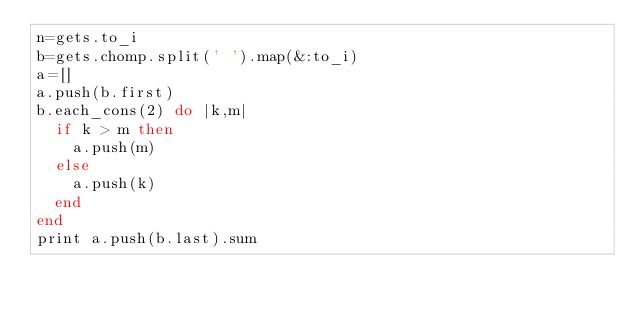Convert code to text. <code><loc_0><loc_0><loc_500><loc_500><_Ruby_>n=gets.to_i
b=gets.chomp.split(' ').map(&:to_i)
a=[]
a.push(b.first)
b.each_cons(2) do |k,m|
  if k > m then
    a.push(m)
  else
    a.push(k)
  end
end
print a.push(b.last).sum
</code> 